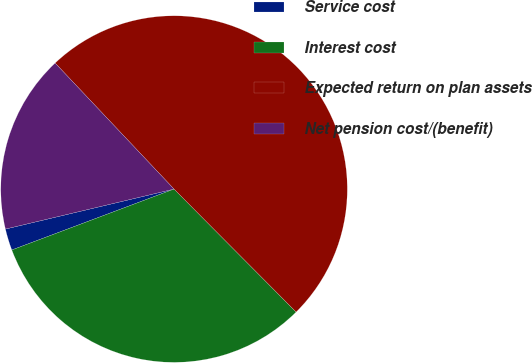Convert chart. <chart><loc_0><loc_0><loc_500><loc_500><pie_chart><fcel>Service cost<fcel>Interest cost<fcel>Expected return on plan assets<fcel>Net pension cost/(benefit)<nl><fcel>2.01%<fcel>31.73%<fcel>49.6%<fcel>16.67%<nl></chart> 